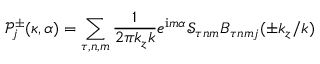Convert formula to latex. <formula><loc_0><loc_0><loc_500><loc_500>\mathcal { P } _ { j } ^ { \pm } ( \kappa , \alpha ) = \sum _ { \tau , n , m } \frac { 1 } { 2 \pi k _ { z } k } e ^ { i m \alpha } \mathcal { S } _ { \tau n m } B _ { \tau n m j } ( \pm k _ { z } / k )</formula> 